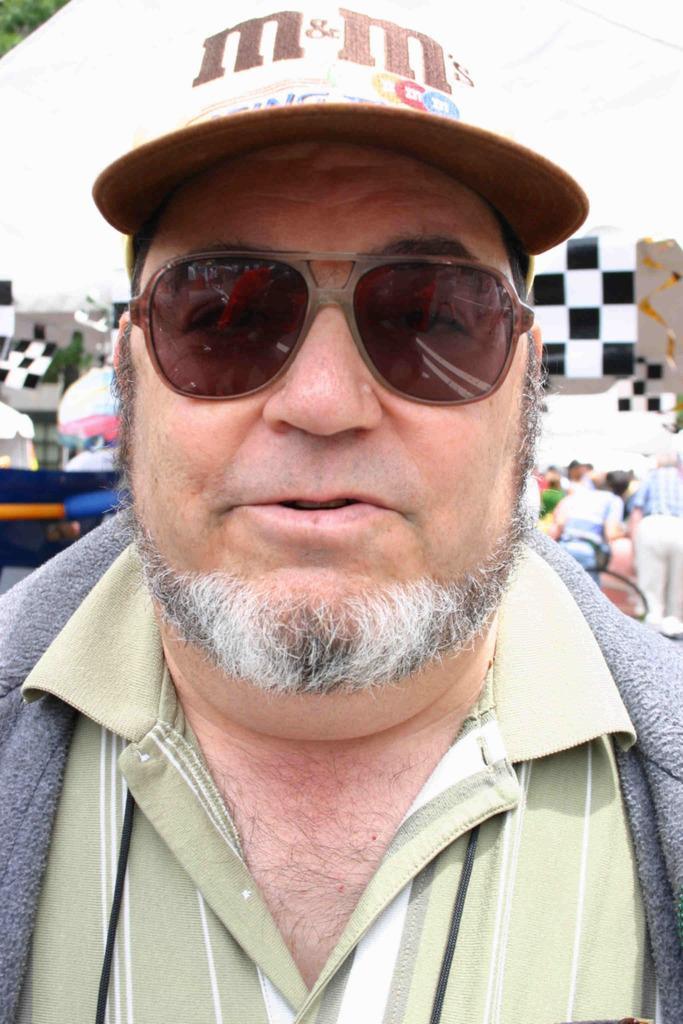In one or two sentences, can you explain what this image depicts? In the front of the image I can see a person wore goggles and cap. In the background of the image there are people and objects.   